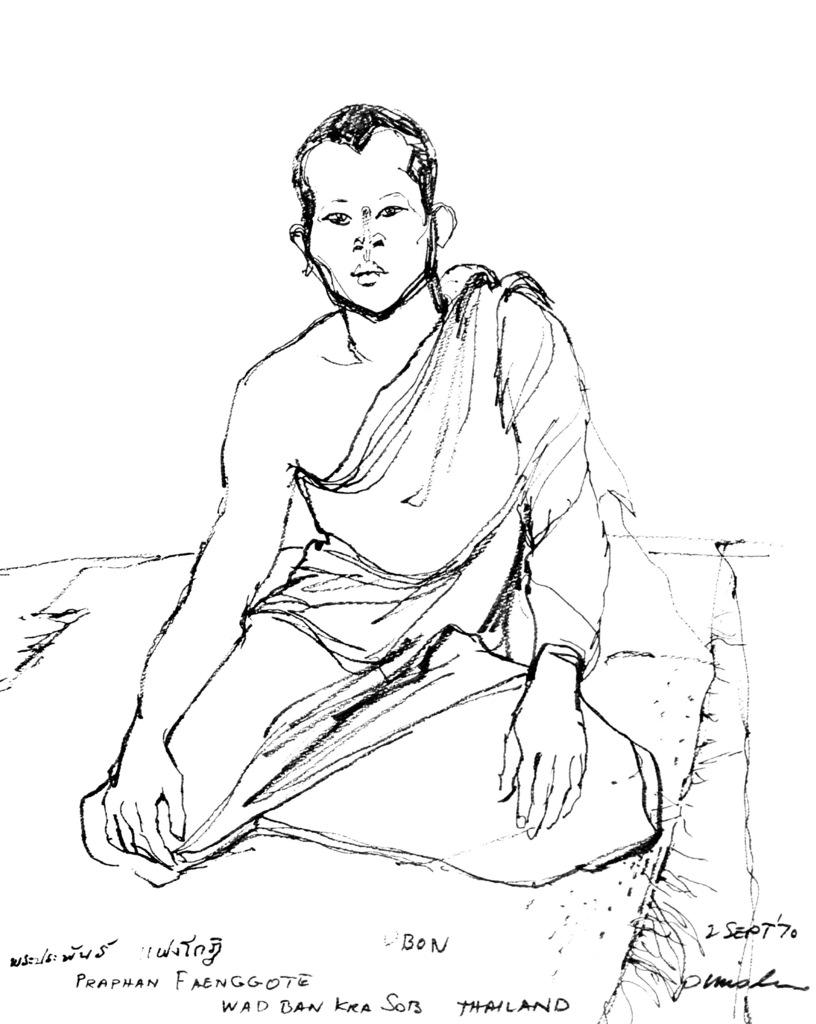What is the main subject of the image? There is a sketch of a person in the image. What else can be seen at the bottom of the image? There is text at the bottom of the image. What color is the background of the image? The background of the image is white. What type of wood can be seen in the image? There is no wood present in the image; it features a sketch of a person and text on a white background. 